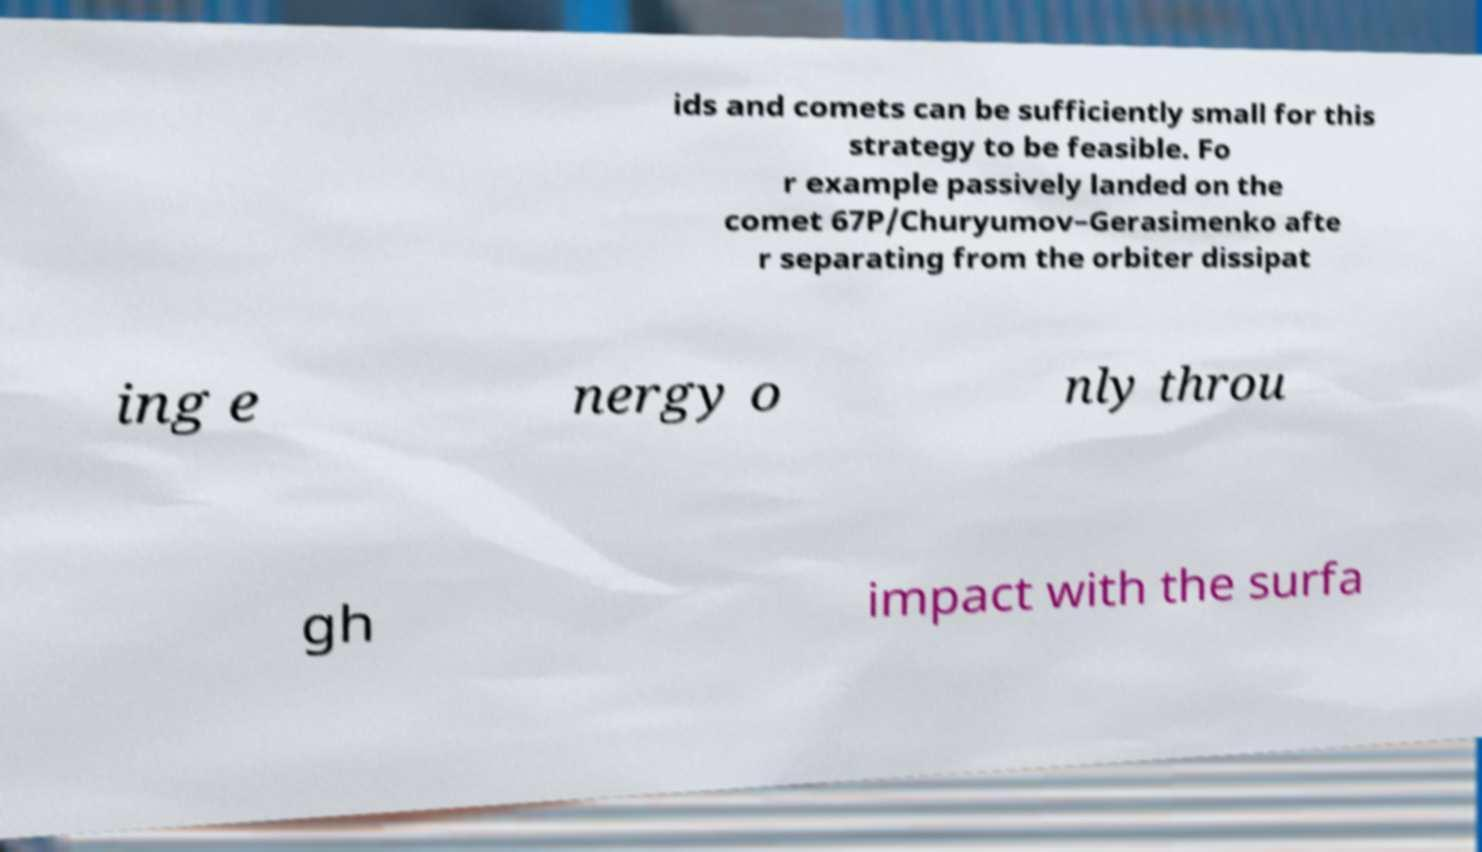Please identify and transcribe the text found in this image. ids and comets can be sufficiently small for this strategy to be feasible. Fo r example passively landed on the comet 67P/Churyumov–Gerasimenko afte r separating from the orbiter dissipat ing e nergy o nly throu gh impact with the surfa 